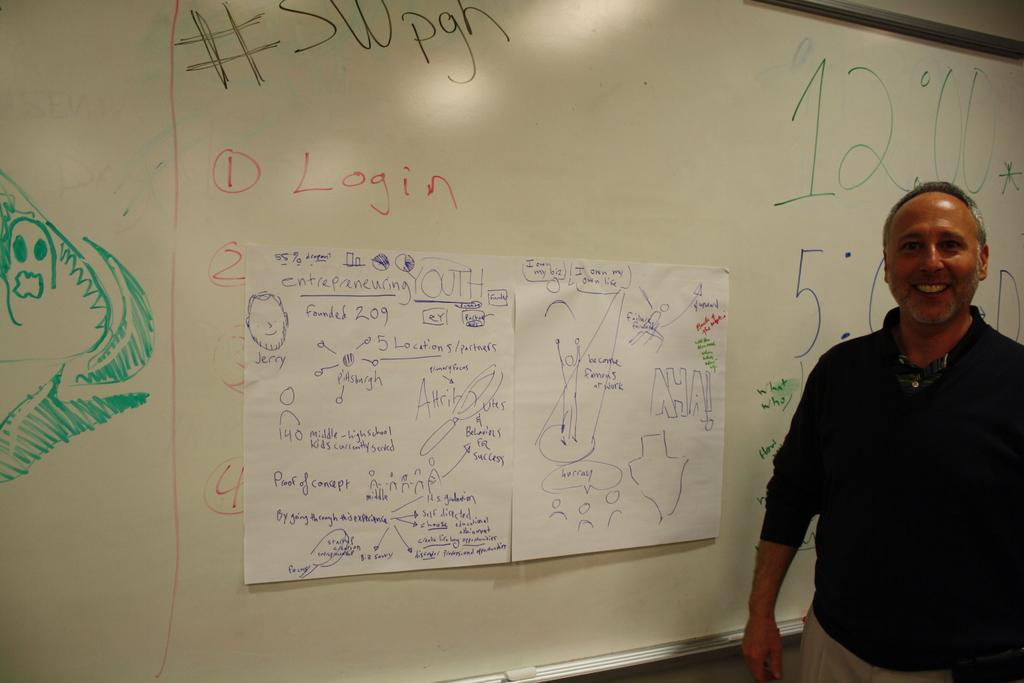What is written on the board?
Your response must be concise. Login. What time is written on the board?
Offer a very short reply. 12:00. 